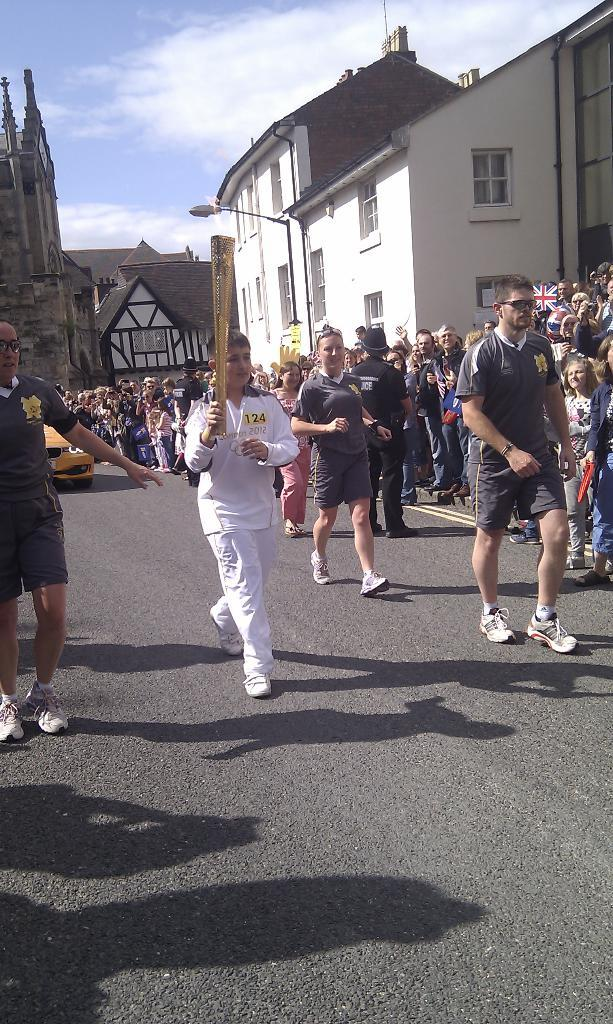What are the people in the image doing? The people in the image are walking. What object is the boy holding in the image? The boy is holding a lamp in his hands. What can be seen in the background of the image? There are houses and a light pole in the background of the image. What is visible in the sky in the image? The sky is visible in the background of the image. What type of joke can be heard being told by the people in the image? There is no indication in the image that the people are telling a joke, so it cannot be determined from the picture. 